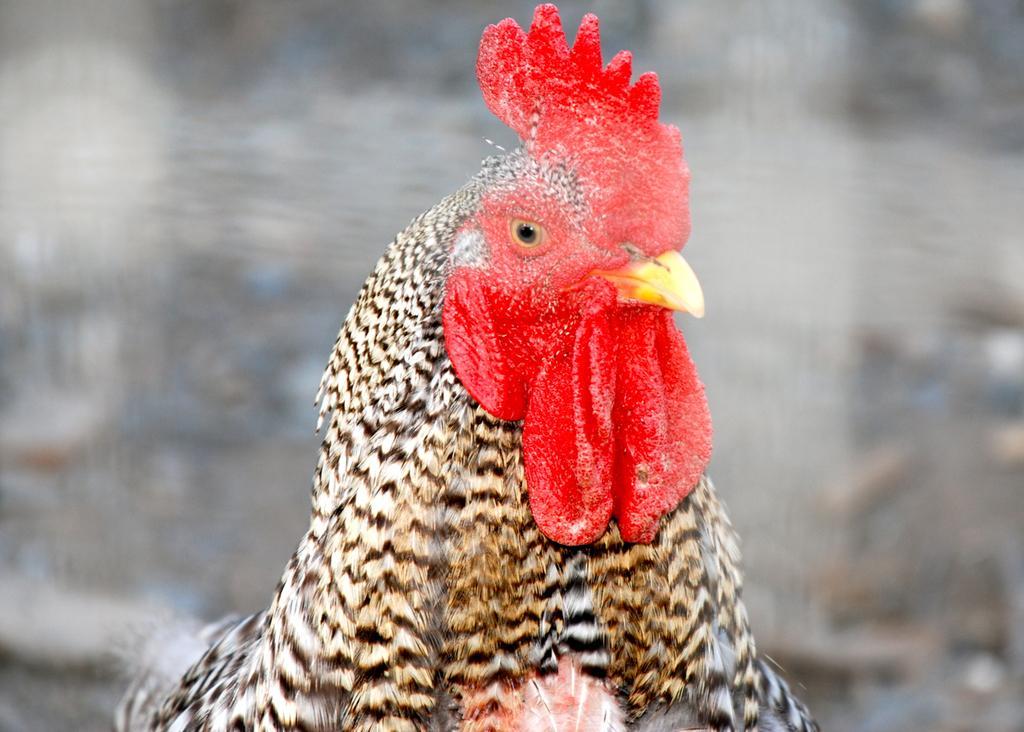Describe this image in one or two sentences. In this image I can see a cock, its feathers are in black and white color. 